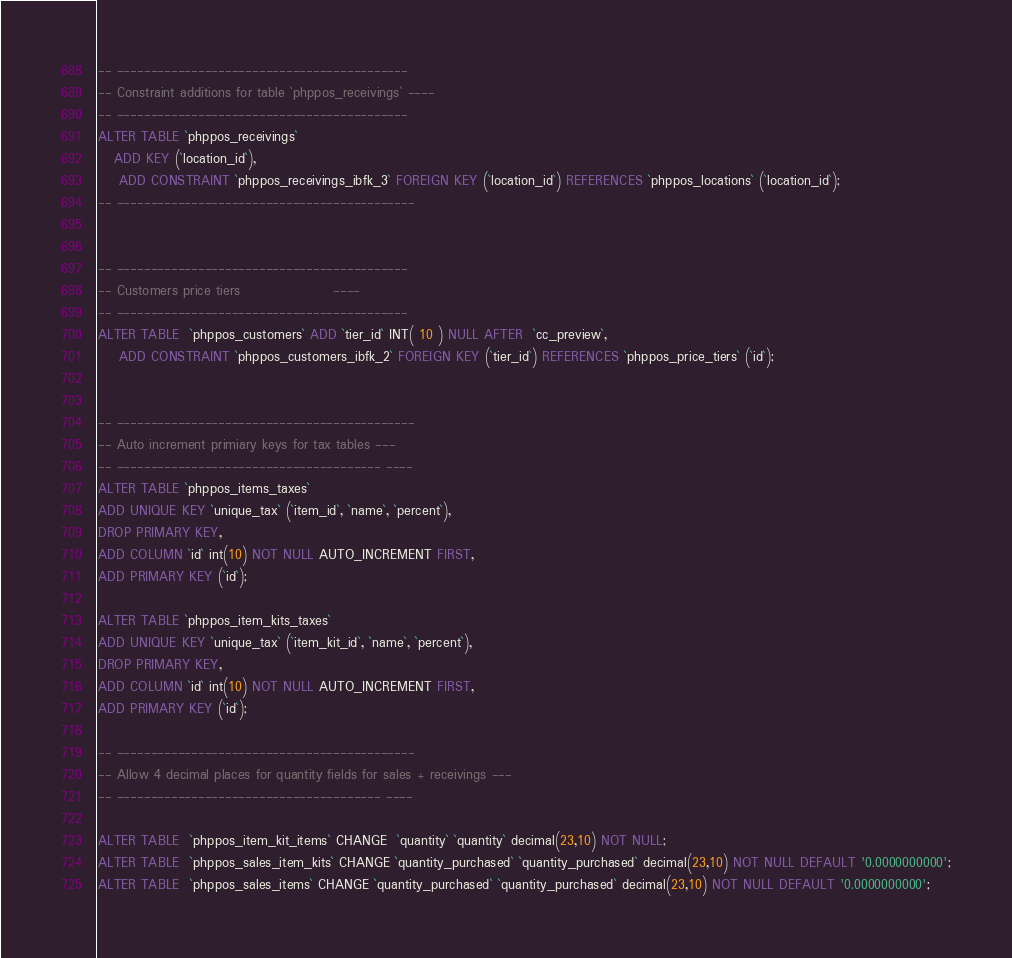Convert code to text. <code><loc_0><loc_0><loc_500><loc_500><_SQL_>
-- -------------------------------------------
-- Constraint additions for table `phppos_receivings` ----
-- -------------------------------------------
ALTER TABLE `phppos_receivings`
   ADD KEY (`location_id`),
	ADD CONSTRAINT `phppos_receivings_ibfk_3` FOREIGN KEY (`location_id`) REFERENCES `phppos_locations` (`location_id`);
-- --------------------------------------------


-- -------------------------------------------
-- Customers price tiers				  ----
-- -------------------------------------------
ALTER TABLE  `phppos_customers` ADD `tier_id` INT( 10 ) NULL AFTER  `cc_preview`,
	ADD CONSTRAINT `phppos_customers_ibfk_2` FOREIGN KEY (`tier_id`) REFERENCES `phppos_price_tiers` (`id`);


-- --------------------------------------------
-- Auto increment primiary keys for tax tables ---
-- --------------------------------------- ----
ALTER TABLE `phppos_items_taxes`
ADD UNIQUE KEY `unique_tax` (`item_id`, `name`, `percent`), 
DROP PRIMARY KEY,
ADD COLUMN `id` int(10) NOT NULL AUTO_INCREMENT FIRST,
ADD PRIMARY KEY (`id`);

ALTER TABLE `phppos_item_kits_taxes`
ADD UNIQUE KEY `unique_tax` (`item_kit_id`, `name`, `percent`), 
DROP PRIMARY KEY,
ADD COLUMN `id` int(10) NOT NULL AUTO_INCREMENT FIRST,
ADD PRIMARY KEY (`id`);

-- --------------------------------------------
-- Allow 4 decimal places for quantity fields for sales + receivings ---
-- --------------------------------------- ----

ALTER TABLE  `phppos_item_kit_items` CHANGE  `quantity` `quantity` decimal(23,10) NOT NULL;
ALTER TABLE  `phppos_sales_item_kits` CHANGE `quantity_purchased` `quantity_purchased` decimal(23,10) NOT NULL DEFAULT '0.0000000000';
ALTER TABLE  `phppos_sales_items` CHANGE `quantity_purchased` `quantity_purchased` decimal(23,10) NOT NULL DEFAULT '0.0000000000';</code> 